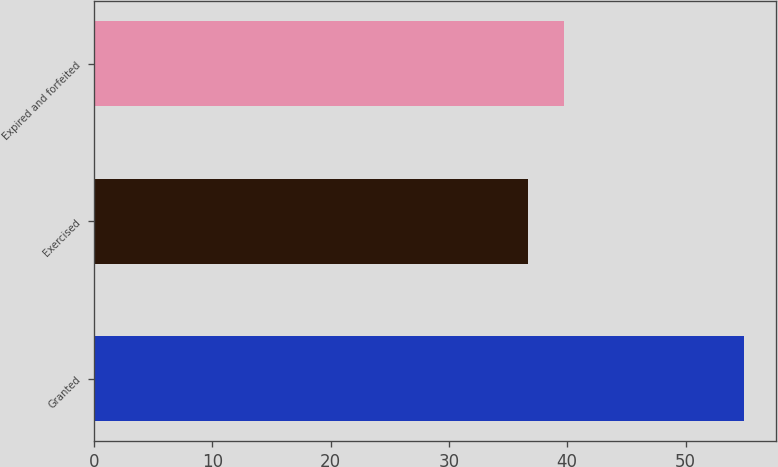Convert chart. <chart><loc_0><loc_0><loc_500><loc_500><bar_chart><fcel>Granted<fcel>Exercised<fcel>Expired and forfeited<nl><fcel>54.91<fcel>36.66<fcel>39.73<nl></chart> 